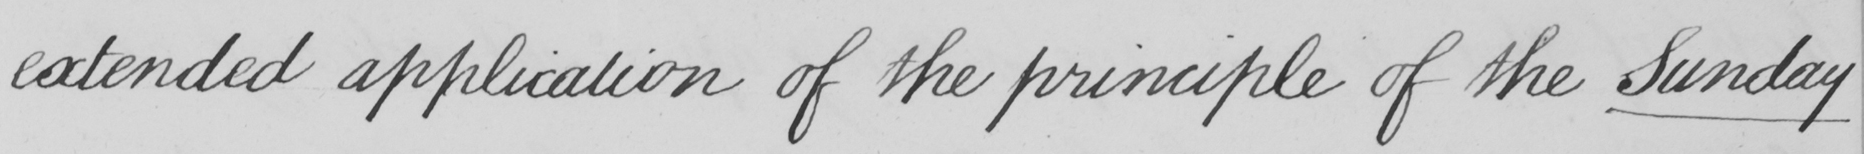What is written in this line of handwriting? extended application of the principle of the Sunday 